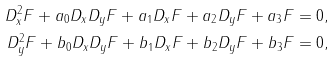Convert formula to latex. <formula><loc_0><loc_0><loc_500><loc_500>D _ { x } ^ { 2 } F + a _ { 0 } D _ { x } D _ { y } F + a _ { 1 } D _ { x } F + a _ { 2 } D _ { y } F + a _ { 3 } F = 0 , \\ D _ { y } ^ { 2 } F + b _ { 0 } D _ { x } D _ { y } F + b _ { 1 } D _ { x } F + b _ { 2 } D _ { y } F + b _ { 3 } F = 0 ,</formula> 